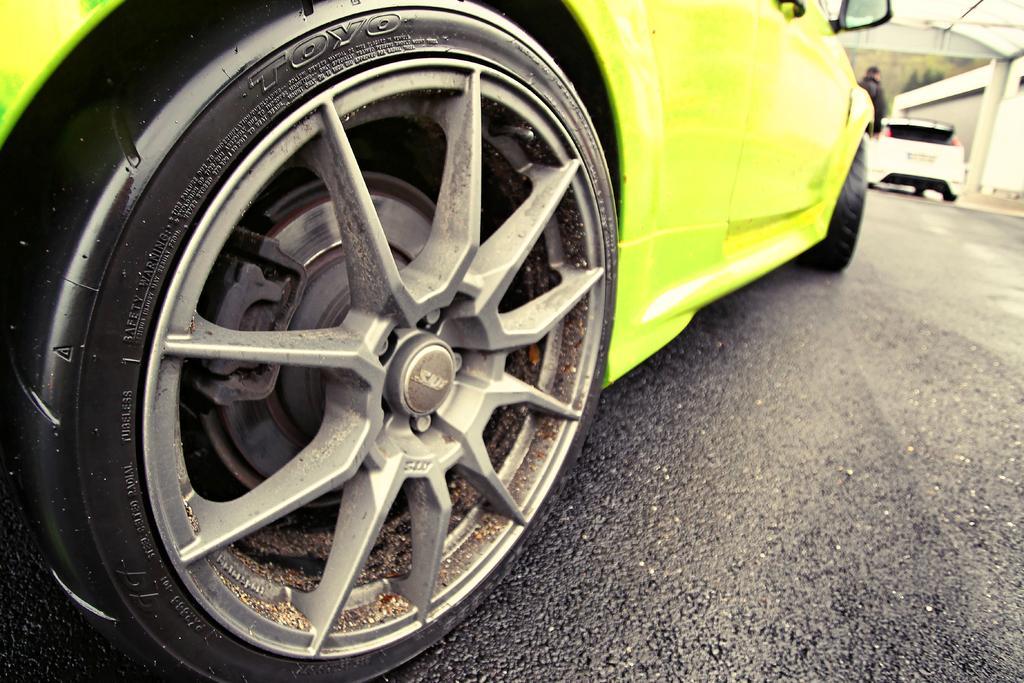Could you give a brief overview of what you see in this image? In the foreground of the picture there is a car on the road. The background is blurred. In the background there are trees, buildings, car and a person. 